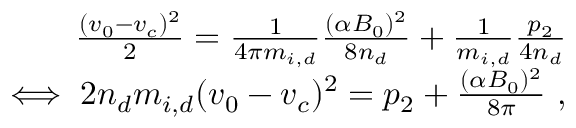<formula> <loc_0><loc_0><loc_500><loc_500>\begin{array} { r } { \frac { ( v _ { 0 } - v _ { c } ) ^ { 2 } } { 2 } = \frac { 1 } { 4 \pi m _ { i , d } } \frac { ( \alpha B _ { 0 } ) ^ { 2 } } { 8 n _ { d } } + \frac { 1 } { m _ { i , d } } \frac { p _ { 2 } } { 4 n _ { d } } } \\ { \iff 2 n _ { d } m _ { i , d } ( v _ { 0 } - v _ { c } ) ^ { 2 } = p _ { 2 } + \frac { ( \alpha B _ { 0 } ) ^ { 2 } } { 8 \pi } \ , } \end{array}</formula> 